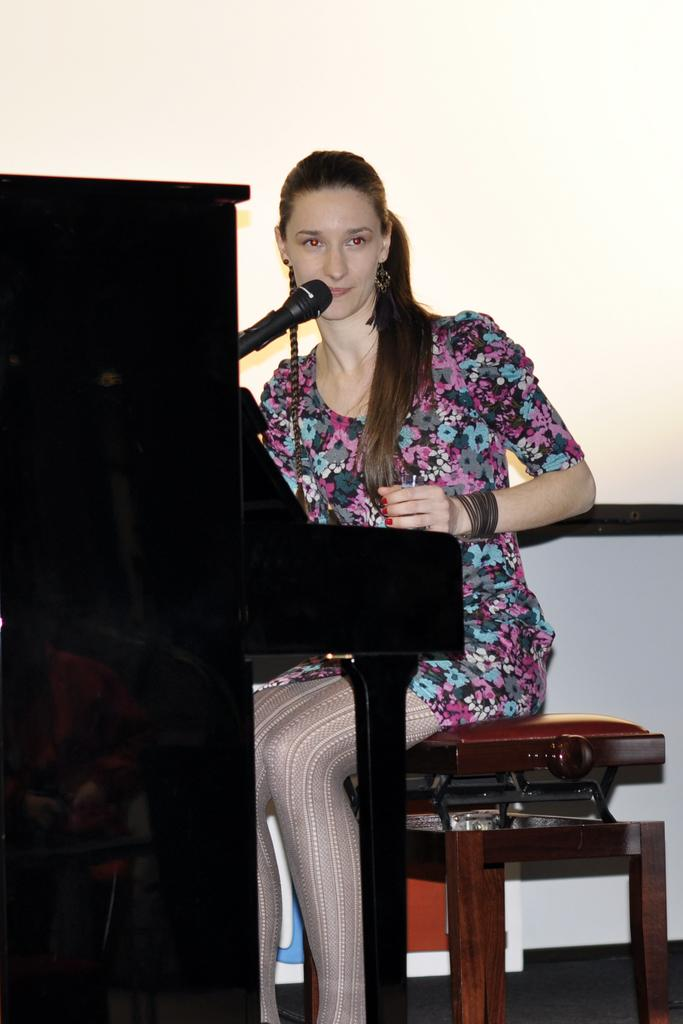Who is present in the image? There is a woman in the image. What is the woman doing in the image? The woman is sitting on a chair in the image. What object can be seen near the woman? There is a microphone in the image. What type of rod is the woman holding in the image? There is no rod present in the image. Can you see any pickles on the chair the woman is sitting on? There are no pickles visible in the image. 